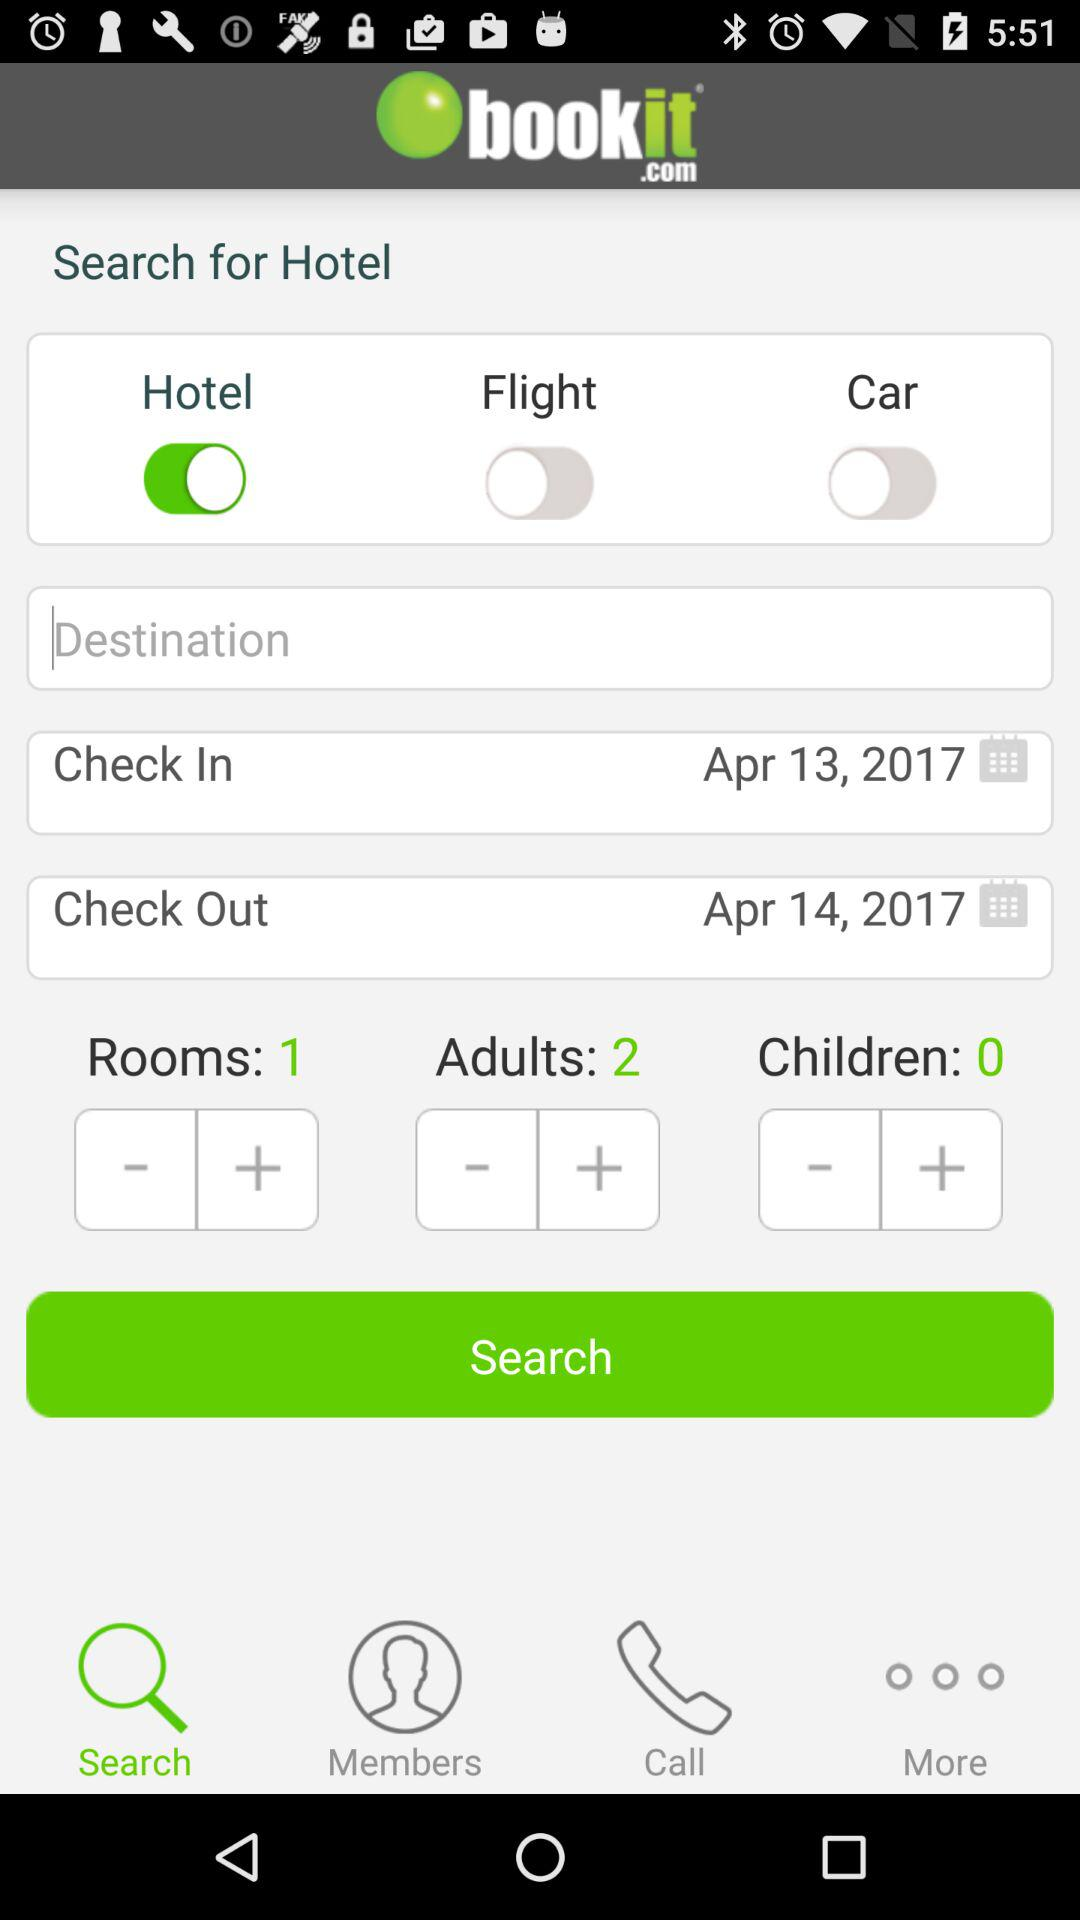What is the current status of the "Car"? The current status of the "Car" is "off". 